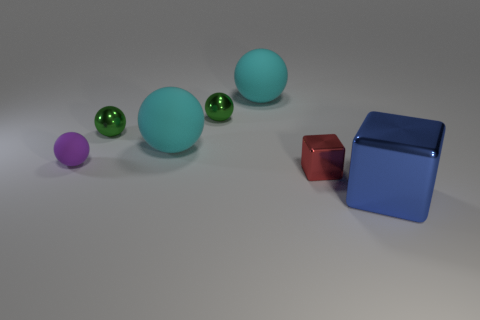What shape is the object in front of the block behind the metal thing that is to the right of the red shiny block?
Ensure brevity in your answer.  Cube. How many things are yellow rubber things or things behind the large blue thing?
Make the answer very short. 6. Is the size of the object right of the red object the same as the small purple matte sphere?
Give a very brief answer. No. What is the object that is on the right side of the small red block made of?
Give a very brief answer. Metal. Are there an equal number of tiny matte objects that are on the right side of the big blue metal block and small balls to the right of the small purple object?
Make the answer very short. No. What color is the other metal thing that is the same shape as the blue thing?
Your answer should be very brief. Red. Are there any other things that have the same color as the small metallic block?
Your answer should be very brief. No. What number of metallic things are either tiny brown blocks or big cyan balls?
Your answer should be compact. 0. Is the color of the tiny block the same as the small matte ball?
Your answer should be very brief. No. Are there more big matte objects in front of the tiny purple sphere than matte balls?
Make the answer very short. No. 